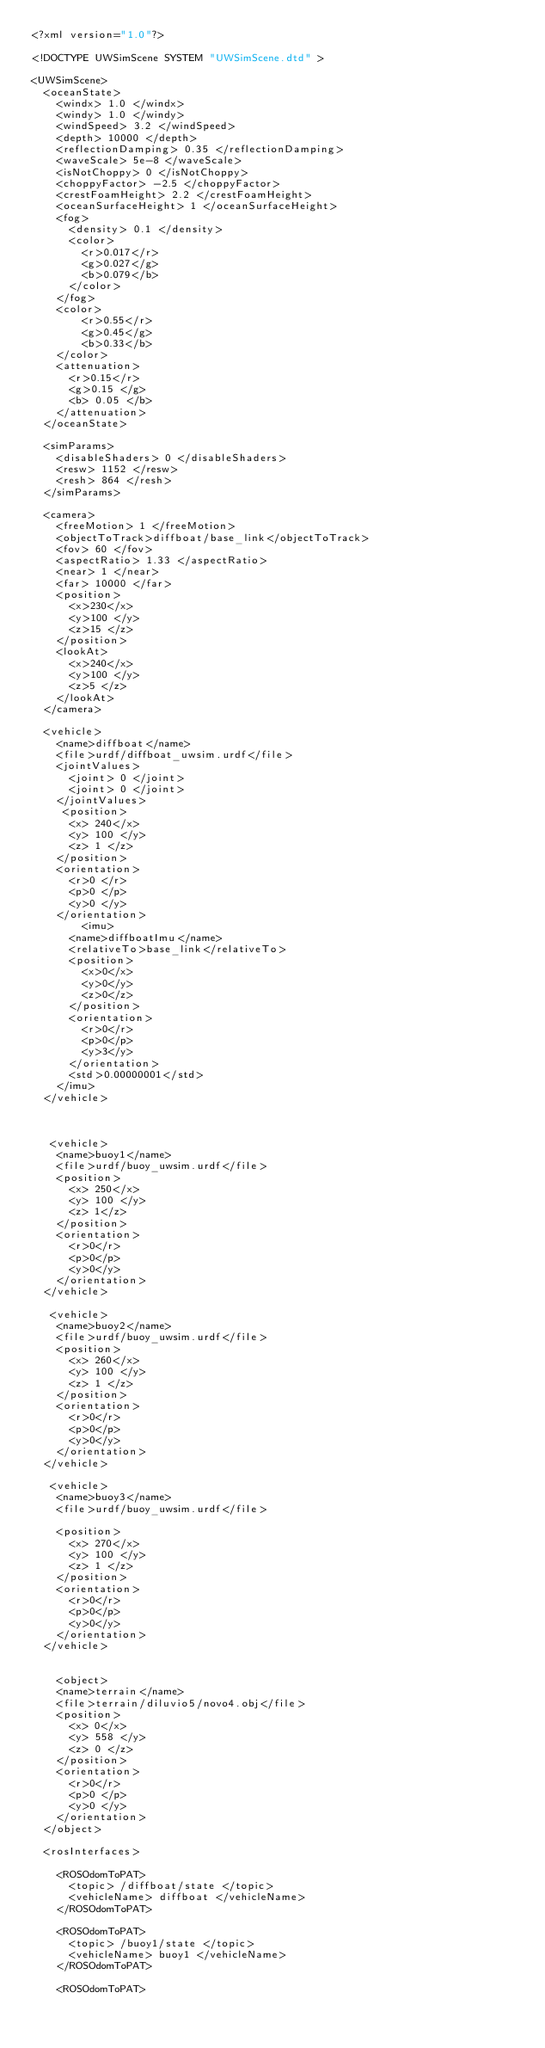Convert code to text. <code><loc_0><loc_0><loc_500><loc_500><_XML_><?xml version="1.0"?>

<!DOCTYPE UWSimScene SYSTEM "UWSimScene.dtd" >

<UWSimScene>
  <oceanState>
    <windx> 1.0 </windx>
    <windy> 1.0 </windy>
    <windSpeed> 3.2 </windSpeed>
    <depth> 10000 </depth>
    <reflectionDamping> 0.35 </reflectionDamping>
    <waveScale> 5e-8 </waveScale>
    <isNotChoppy> 0 </isNotChoppy>
    <choppyFactor> -2.5 </choppyFactor>
    <crestFoamHeight> 2.2 </crestFoamHeight>
    <oceanSurfaceHeight> 1 </oceanSurfaceHeight>
    <fog>
      <density> 0.1 </density>
      <color>
        <r>0.017</r>
        <g>0.027</g>
        <b>0.079</b>
      </color>
    </fog>
    <color>
        <r>0.55</r>
        <g>0.45</g>
        <b>0.33</b>
    </color>
    <attenuation>
      <r>0.15</r>
      <g>0.15 </g>
      <b> 0.05 </b>
    </attenuation>
  </oceanState>
  
  <simParams>
    <disableShaders> 0 </disableShaders>
    <resw> 1152 </resw>
    <resh> 864 </resh>
  </simParams>

  <camera>
    <freeMotion> 1 </freeMotion>
    <objectToTrack>diffboat/base_link</objectToTrack>
    <fov> 60 </fov>
    <aspectRatio> 1.33 </aspectRatio>
    <near> 1 </near>
    <far> 10000 </far>
    <position>
      <x>230</x>
      <y>100 </y>
      <z>15 </z>
    </position> 
    <lookAt>
      <x>240</x>
      <y>100 </y>
      <z>5 </z>
    </lookAt>
  </camera>

  <vehicle>
    <name>diffboat</name>
    <file>urdf/diffboat_uwsim.urdf</file>
    <jointValues>
      <joint> 0 </joint>
      <joint> 0 </joint>
    </jointValues>
     <position>
      <x> 240</x>
      <y> 100 </y>
      <z> 1 </z>
    </position>
    <orientation>
      <r>0 </r>
      <p>0 </p>
      <y>0 </y>
    </orientation>
        <imu>
      <name>diffboatImu</name>
      <relativeTo>base_link</relativeTo>
      <position>
        <x>0</x>
        <y>0</y>
        <z>0</z>
      </position>  
      <orientation>
        <r>0</r>
        <p>0</p>
        <y>3</y>
      </orientation>
      <std>0.00000001</std>
    </imu>
  </vehicle>
  


   <vehicle>
    <name>buoy1</name>
    <file>urdf/buoy_uwsim.urdf</file>
    <position>
      <x> 250</x>
      <y> 100 </y>
      <z> 1</z>
    </position>
    <orientation>
      <r>0</r>
      <p>0</p>
      <y>0</y>
    </orientation>
  </vehicle>
  
   <vehicle>
    <name>buoy2</name>
    <file>urdf/buoy_uwsim.urdf</file>
    <position>
      <x> 260</x>
      <y> 100 </y>
      <z> 1 </z>
    </position>
    <orientation>
      <r>0</r>
      <p>0</p>
      <y>0</y>
    </orientation>
  </vehicle>

   <vehicle>
    <name>buoy3</name>
    <file>urdf/buoy_uwsim.urdf</file>

    <position>
      <x> 270</x>
      <y> 100 </y>
      <z> 1 </z>
    </position>
    <orientation>
      <r>0</r>
      <p>0</p>
      <y>0</y>
    </orientation>
  </vehicle>


	<object>
    <name>terrain</name>
    <file>terrain/diluvio5/novo4.obj</file>
    <position>
      <x> 0</x>
      <y> 558 </y>
      <z> 0 </z>
    </position>
    <orientation>
      <r>0</r>
      <p>0 </p>
      <y>0 </y>
    </orientation>
  </object>

  <rosInterfaces>   

    <ROSOdomToPAT>
      <topic> /diffboat/state </topic>
      <vehicleName> diffboat </vehicleName>
    </ROSOdomToPAT>

    <ROSOdomToPAT>
      <topic> /buoy1/state </topic>
      <vehicleName> buoy1 </vehicleName>
    </ROSOdomToPAT> 
    
    <ROSOdomToPAT></code> 